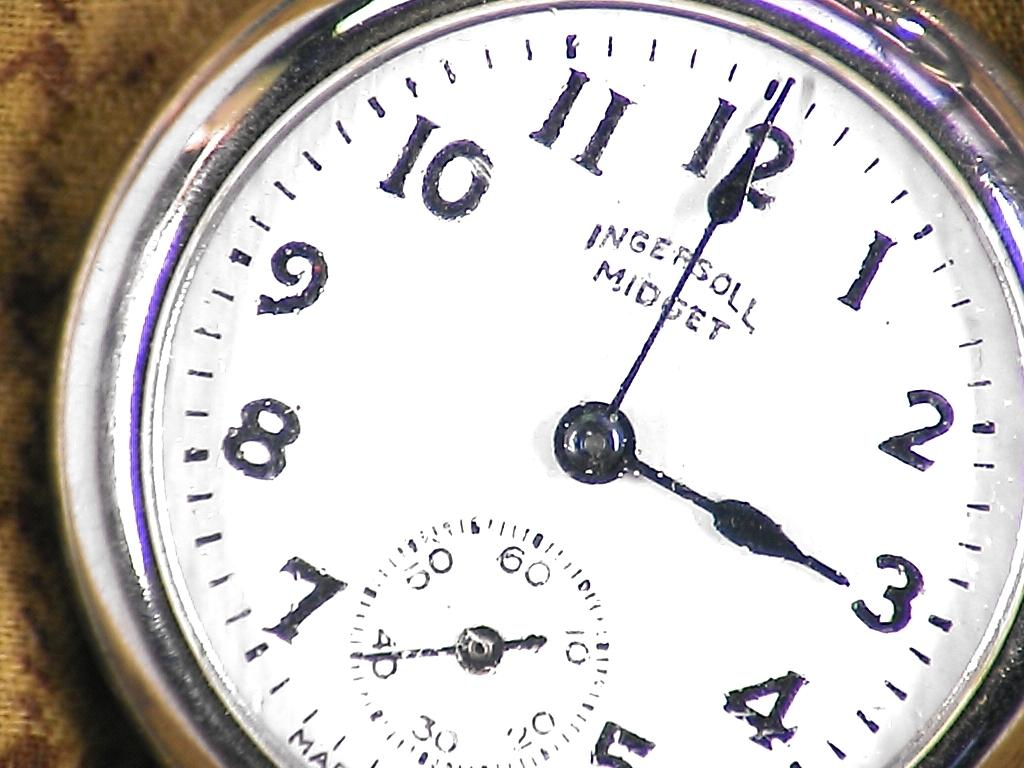<image>
Render a clear and concise summary of the photo. Face of a watch that says the words Ingersoll Midget on it. 